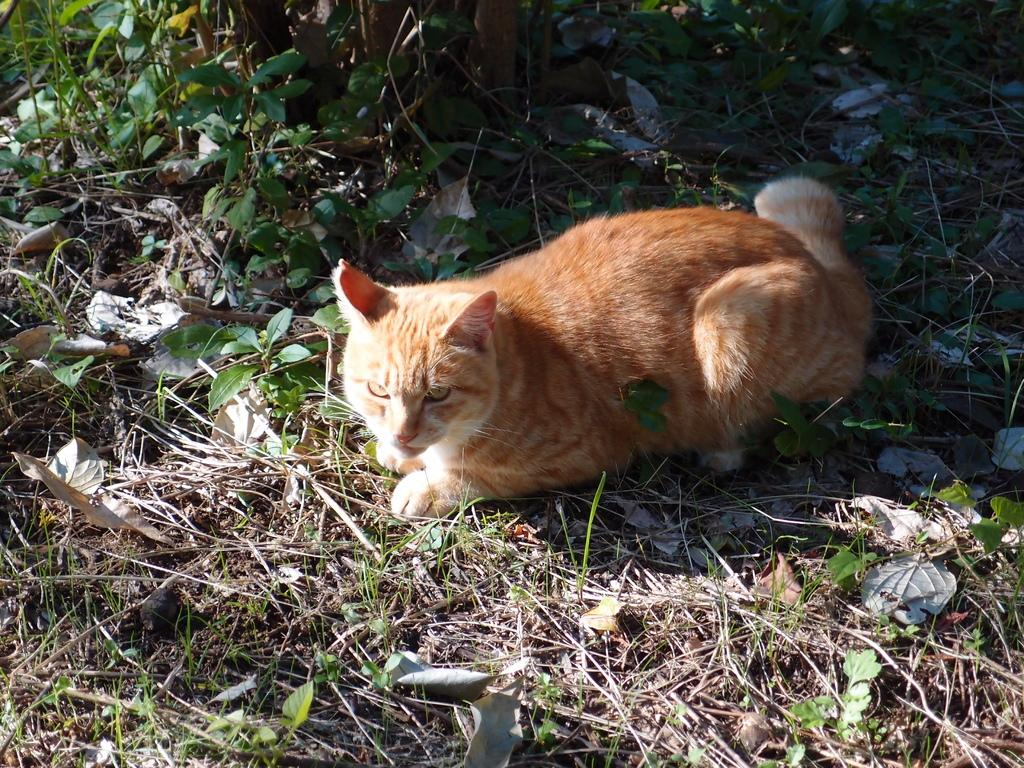What is the main subject of the image? There is a cat in the center of the image. What is the cat doing in the image? The cat is lying on the ground. What can be seen in the background of the image? There are plants and leaves present in the background of the image. What type of snow can be seen falling in the image? There is no snow present in the image; it features a cat lying on the ground with plants and leaves in the background. 